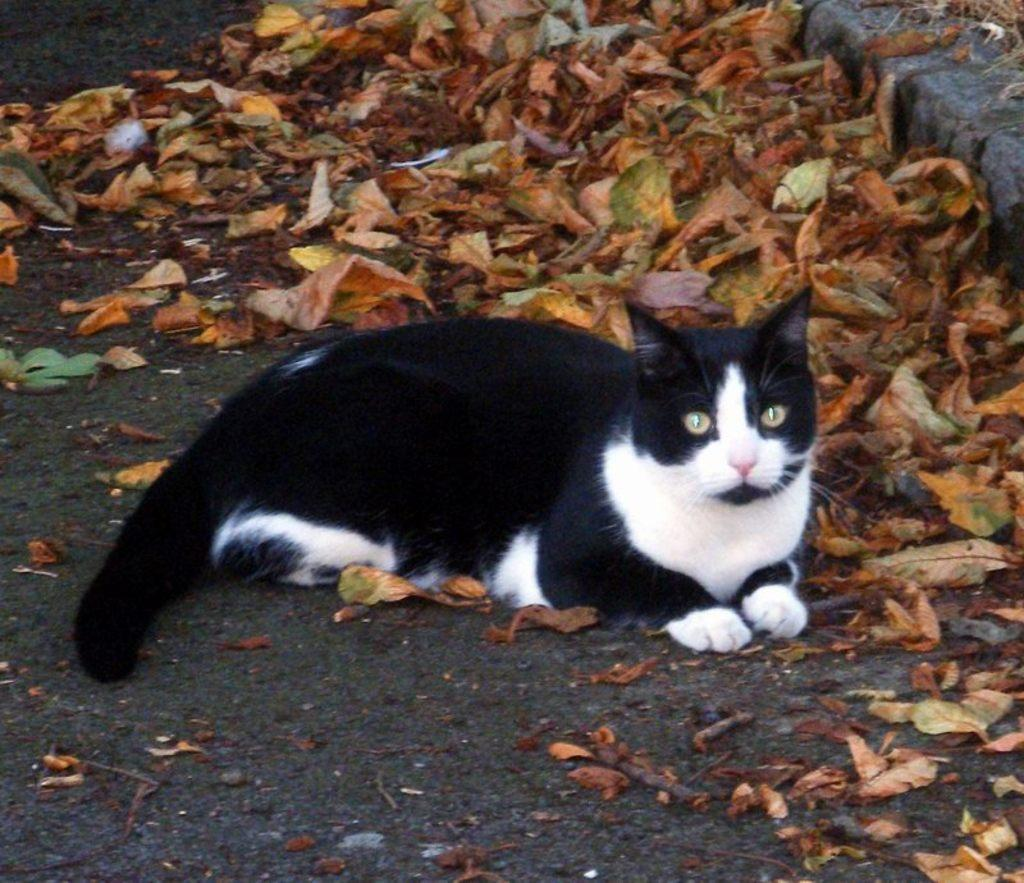What animal is present in the image? There is a cat in the image. Where is the cat located in the image? The cat is sitting on the ground. What is the color scheme of the image? The image is in black and white. What type of natural elements can be seen in the image? There are dried leaves on the top of the image. Where is the harbor located in the image? There is no harbor present in the image. Is there a crib visible in the image? There is no crib present in the image. 